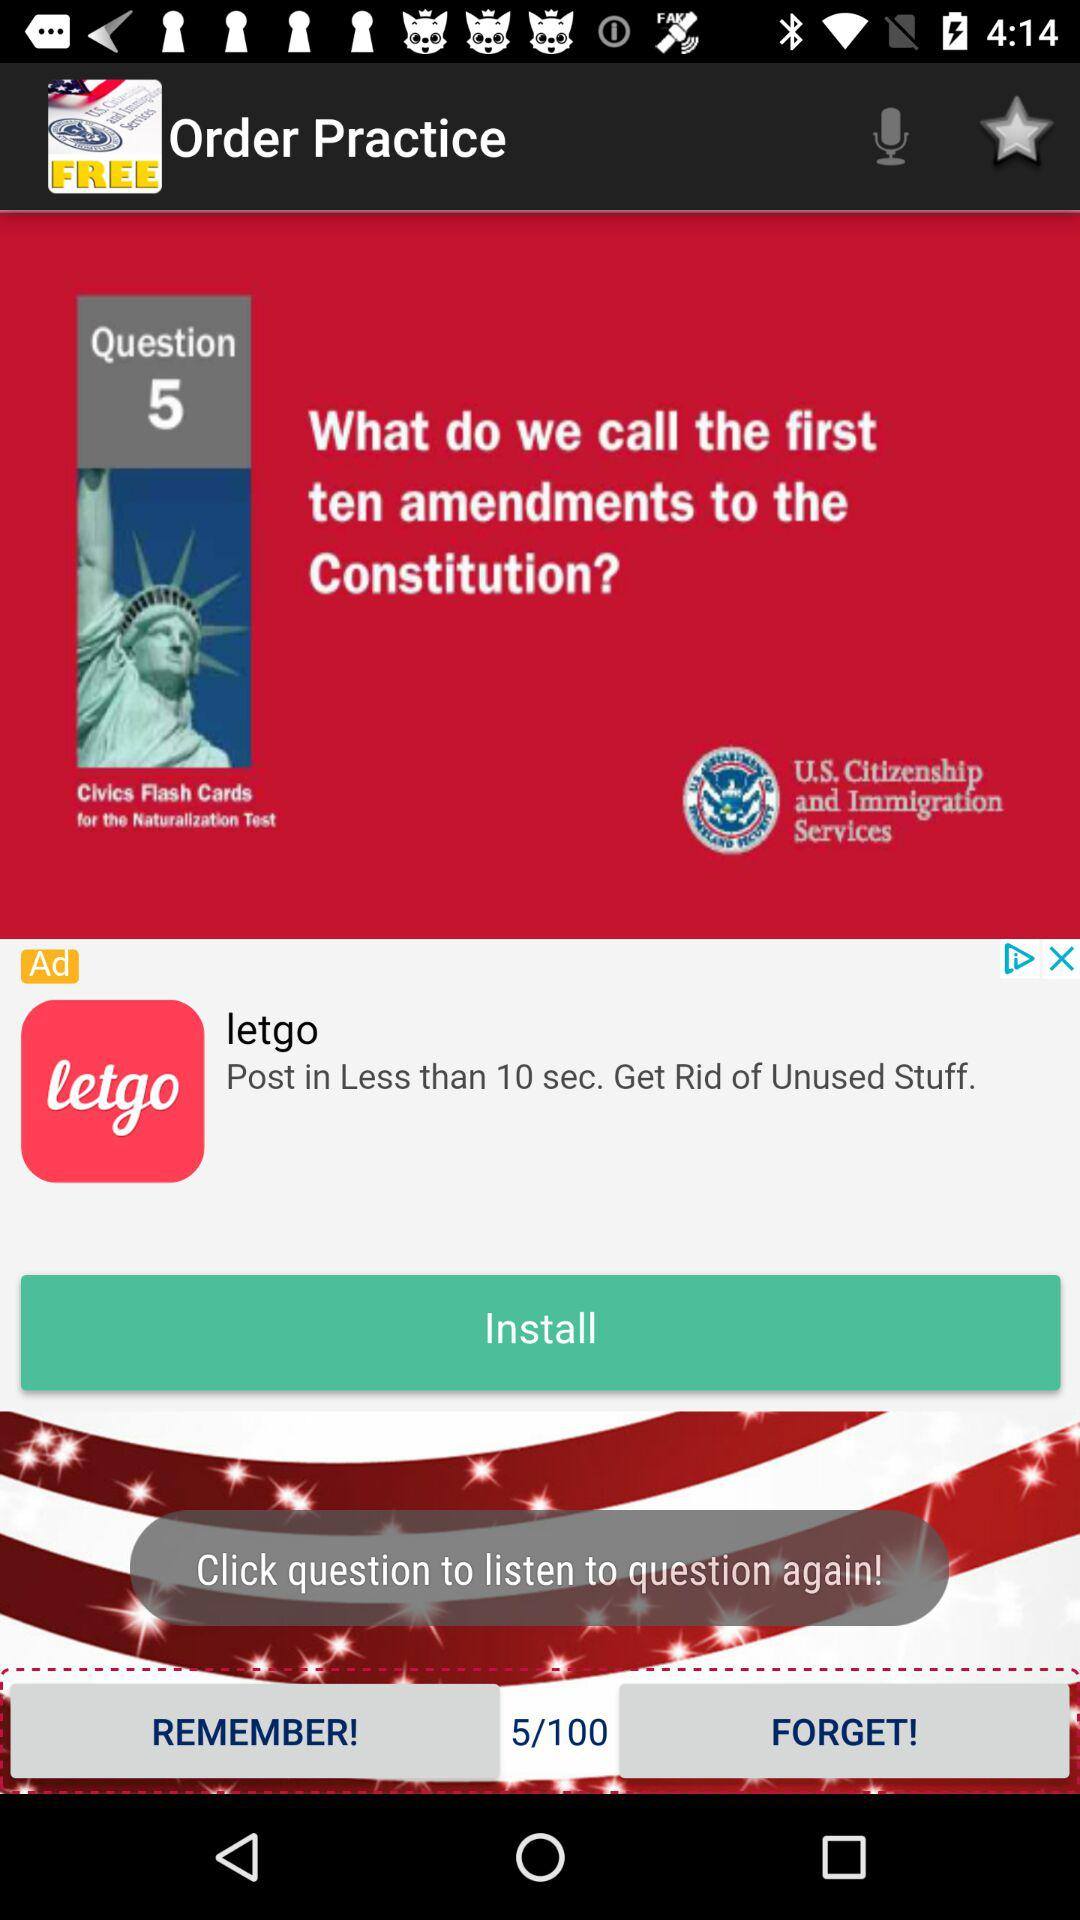What question number is shown? The question number shown is 5. 